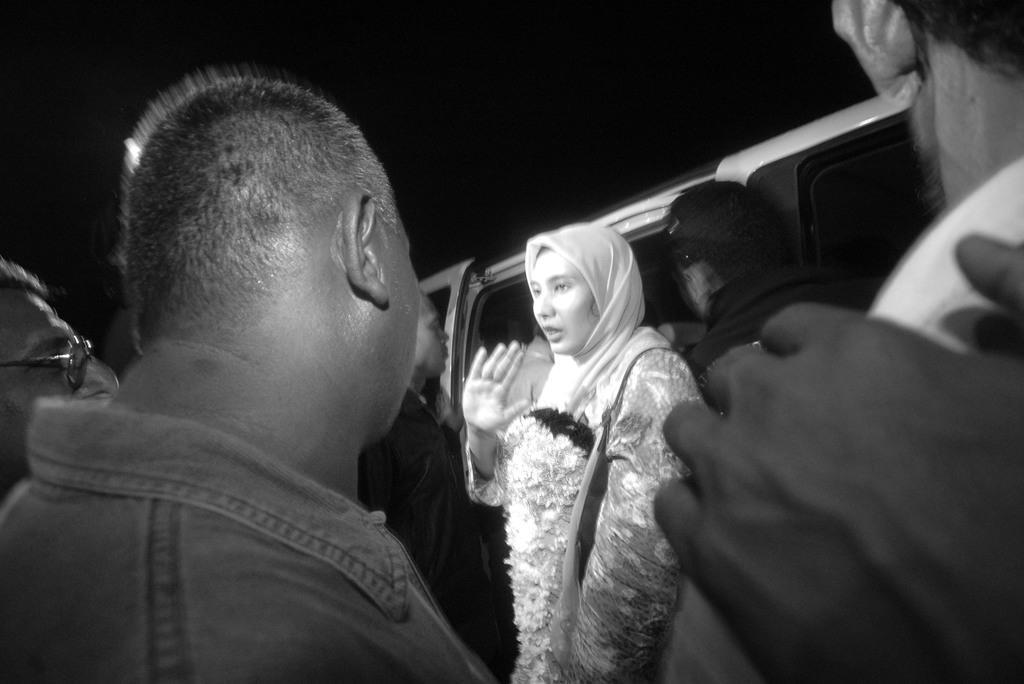How would you summarize this image in a sentence or two? This is a black and white picture of few persons standing in the front, in the middle there is an arab woman with garland standing in front of a vehicle. 